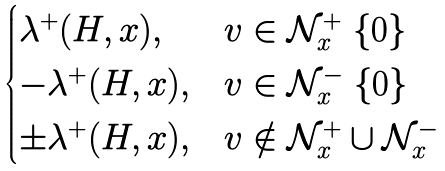<formula> <loc_0><loc_0><loc_500><loc_500>\begin{cases} \lambda ^ { + } ( H , x ) , & { v } \in { \mathcal { N } _ { x } ^ { + } } \ \{ { 0 } \} \\ - \lambda ^ { + } ( H , x ) , & { v } \in { \mathcal { N } _ { x } ^ { - } } \ \{ { 0 } \} \\ \pm \lambda ^ { + } ( H , x ) , & { v } \notin { \mathcal { N } _ { x } ^ { + } } \cup \mathcal { N } _ { x } ^ { - } \end{cases}</formula> 